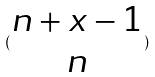Convert formula to latex. <formula><loc_0><loc_0><loc_500><loc_500>( \begin{matrix} n + x - 1 \\ n \end{matrix} )</formula> 